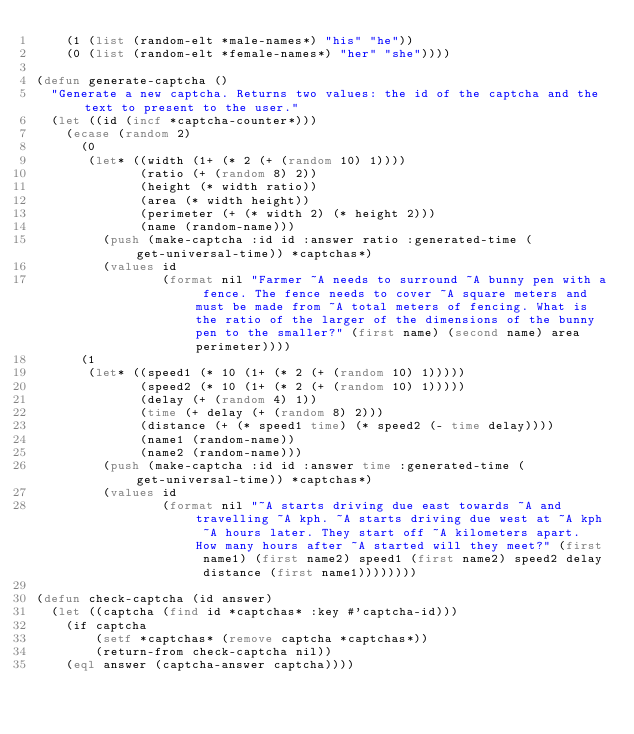Convert code to text. <code><loc_0><loc_0><loc_500><loc_500><_Lisp_>    (1 (list (random-elt *male-names*) "his" "he"))
    (0 (list (random-elt *female-names*) "her" "she"))))

(defun generate-captcha ()
  "Generate a new captcha. Returns two values: the id of the captcha and the text to present to the user."
  (let ((id (incf *captcha-counter*)))
    (ecase (random 2)
      (0
       (let* ((width (1+ (* 2 (+ (random 10) 1))))
              (ratio (+ (random 8) 2))
              (height (* width ratio))
              (area (* width height))
              (perimeter (+ (* width 2) (* height 2)))
              (name (random-name)))
         (push (make-captcha :id id :answer ratio :generated-time (get-universal-time)) *captchas*)
         (values id
                 (format nil "Farmer ~A needs to surround ~A bunny pen with a fence. The fence needs to cover ~A square meters and must be made from ~A total meters of fencing. What is the ratio of the larger of the dimensions of the bunny pen to the smaller?" (first name) (second name) area perimeter))))
      (1
       (let* ((speed1 (* 10 (1+ (* 2 (+ (random 10) 1)))))
              (speed2 (* 10 (1+ (* 2 (+ (random 10) 1)))))
              (delay (+ (random 4) 1))
              (time (+ delay (+ (random 8) 2)))
              (distance (+ (* speed1 time) (* speed2 (- time delay))))
              (name1 (random-name))
              (name2 (random-name)))
         (push (make-captcha :id id :answer time :generated-time (get-universal-time)) *captchas*)
         (values id
                 (format nil "~A starts driving due east towards ~A and travelling ~A kph. ~A starts driving due west at ~A kph ~A hours later. They start off ~A kilometers apart. How many hours after ~A started will they meet?" (first name1) (first name2) speed1 (first name2) speed2 delay distance (first name1))))))))

(defun check-captcha (id answer)
  (let ((captcha (find id *captchas* :key #'captcha-id)))
    (if captcha
        (setf *captchas* (remove captcha *captchas*))
        (return-from check-captcha nil))
    (eql answer (captcha-answer captcha))))</code> 